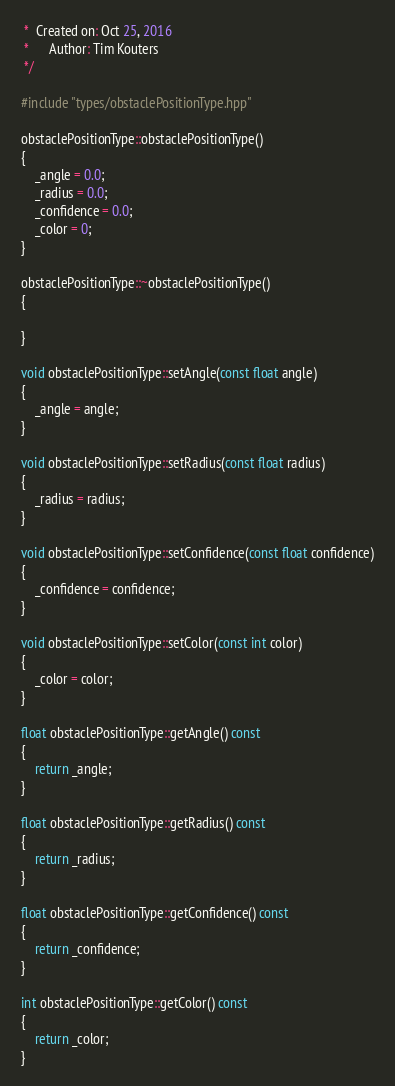Convert code to text. <code><loc_0><loc_0><loc_500><loc_500><_C++_> *  Created on: Oct 25, 2016
 *      Author: Tim Kouters
 */

#include "types/obstaclePositionType.hpp"

obstaclePositionType::obstaclePositionType()
{
	_angle = 0.0;
	_radius = 0.0;
	_confidence = 0.0;
	_color = 0;
}

obstaclePositionType::~obstaclePositionType()
{

}

void obstaclePositionType::setAngle(const float angle)
{
	_angle = angle;
}

void obstaclePositionType::setRadius(const float radius)
{
	_radius = radius;
}

void obstaclePositionType::setConfidence(const float confidence)
{
	_confidence = confidence;
}

void obstaclePositionType::setColor(const int color)
{
	_color = color;
}

float obstaclePositionType::getAngle() const
{
	return _angle;
}

float obstaclePositionType::getRadius() const
{
	return _radius;
}

float obstaclePositionType::getConfidence() const
{
	return _confidence;
}

int obstaclePositionType::getColor() const
{
	return _color;
}
</code> 